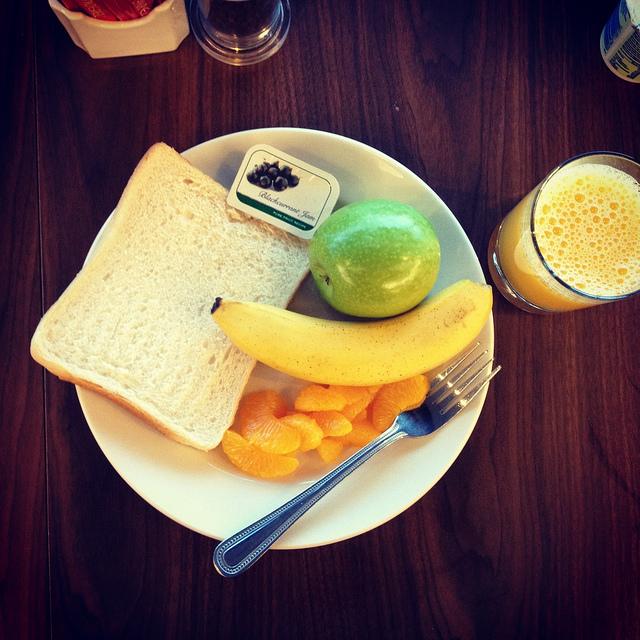Is there coffee in the table?
Give a very brief answer. No. What type of beverage is in the glass?
Answer briefly. Orange juice. Could this be considered a healthy breakfast?
Short answer required. Yes. Is the middle or the end of the banana on top of the apple?
Concise answer only. Middle. Is the bread sliced?
Keep it brief. Yes. How many apples are seen?
Be succinct. 1. 